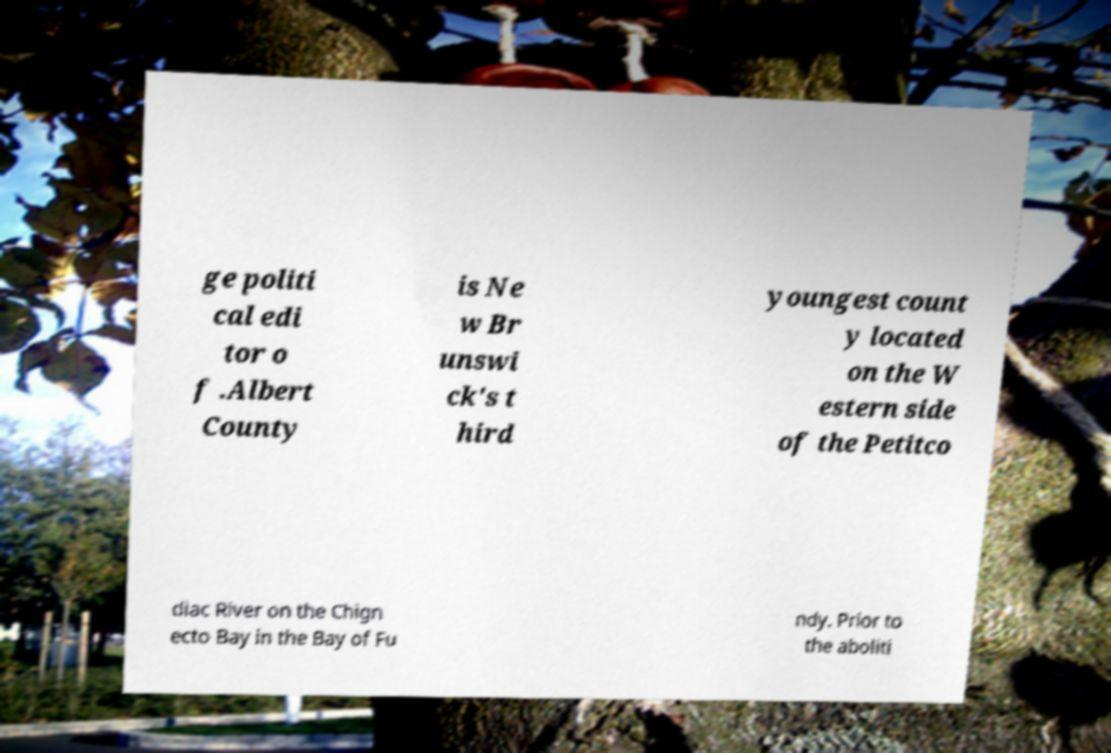Please identify and transcribe the text found in this image. ge politi cal edi tor o f .Albert County is Ne w Br unswi ck's t hird youngest count y located on the W estern side of the Petitco diac River on the Chign ecto Bay in the Bay of Fu ndy. Prior to the aboliti 